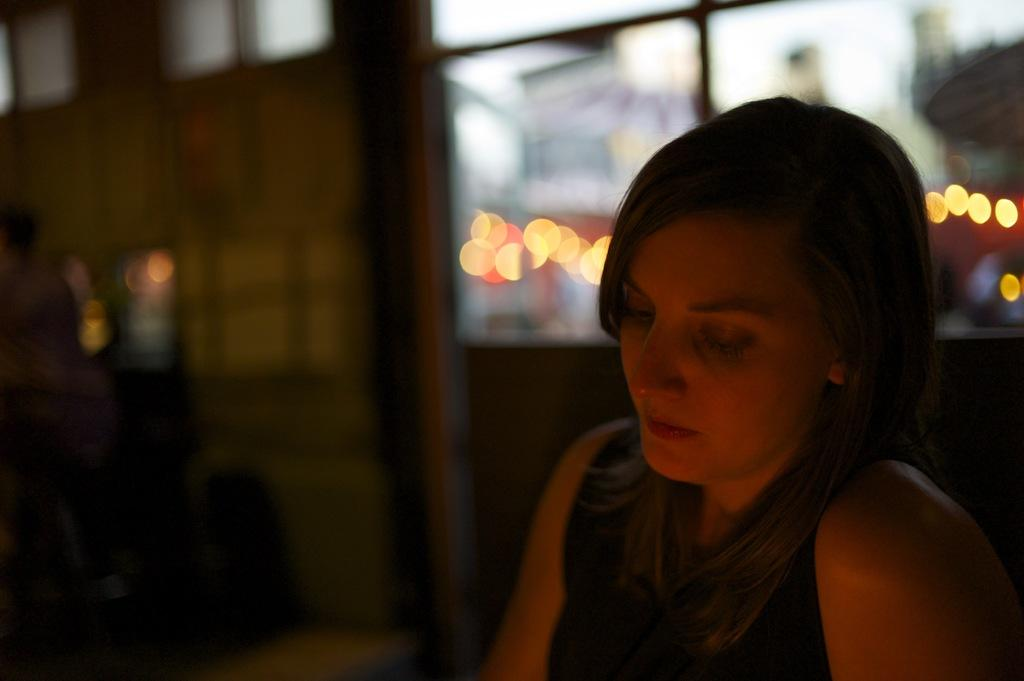Who is present in the image? There is a woman in the image. What can be seen in the background of the image? There is a wall in the background of the image. How would you describe the background of the image? The background appears blurry. What type of list can be seen on the wall in the image? There is no list present on the wall in the image. How many spiders are visible on the woman's shoulder in the image? There are no spiders visible on the woman's shoulder in the image. 